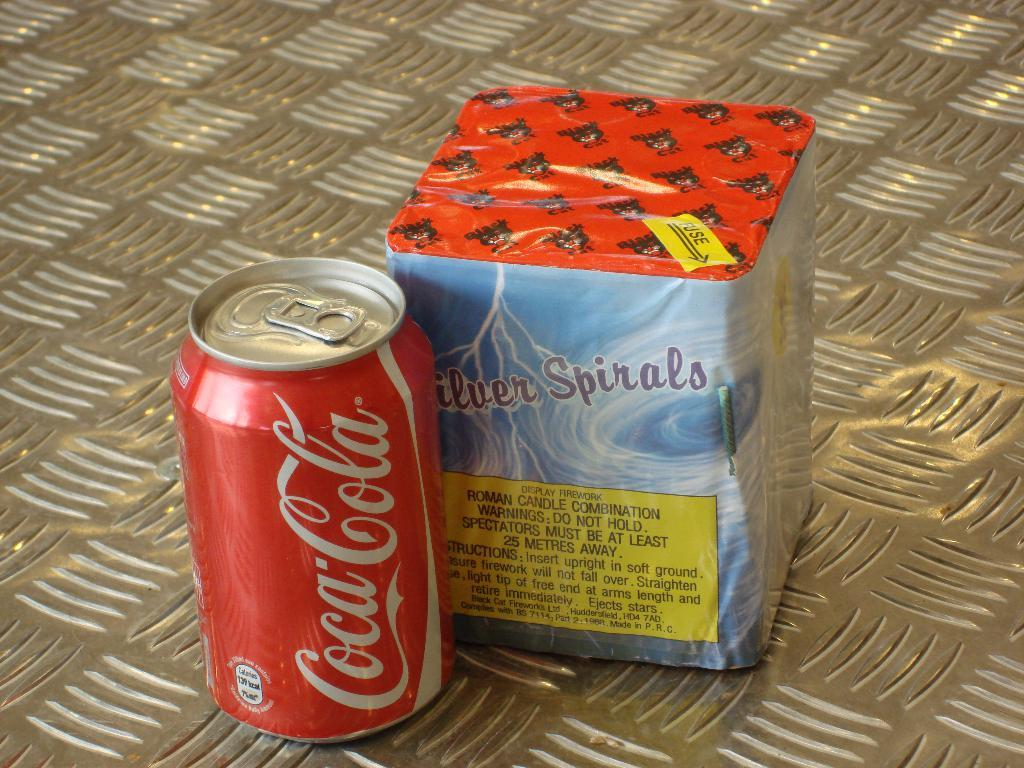<image>
Summarize the visual content of the image. A can of Coca Cola sits next to a roman candle. 